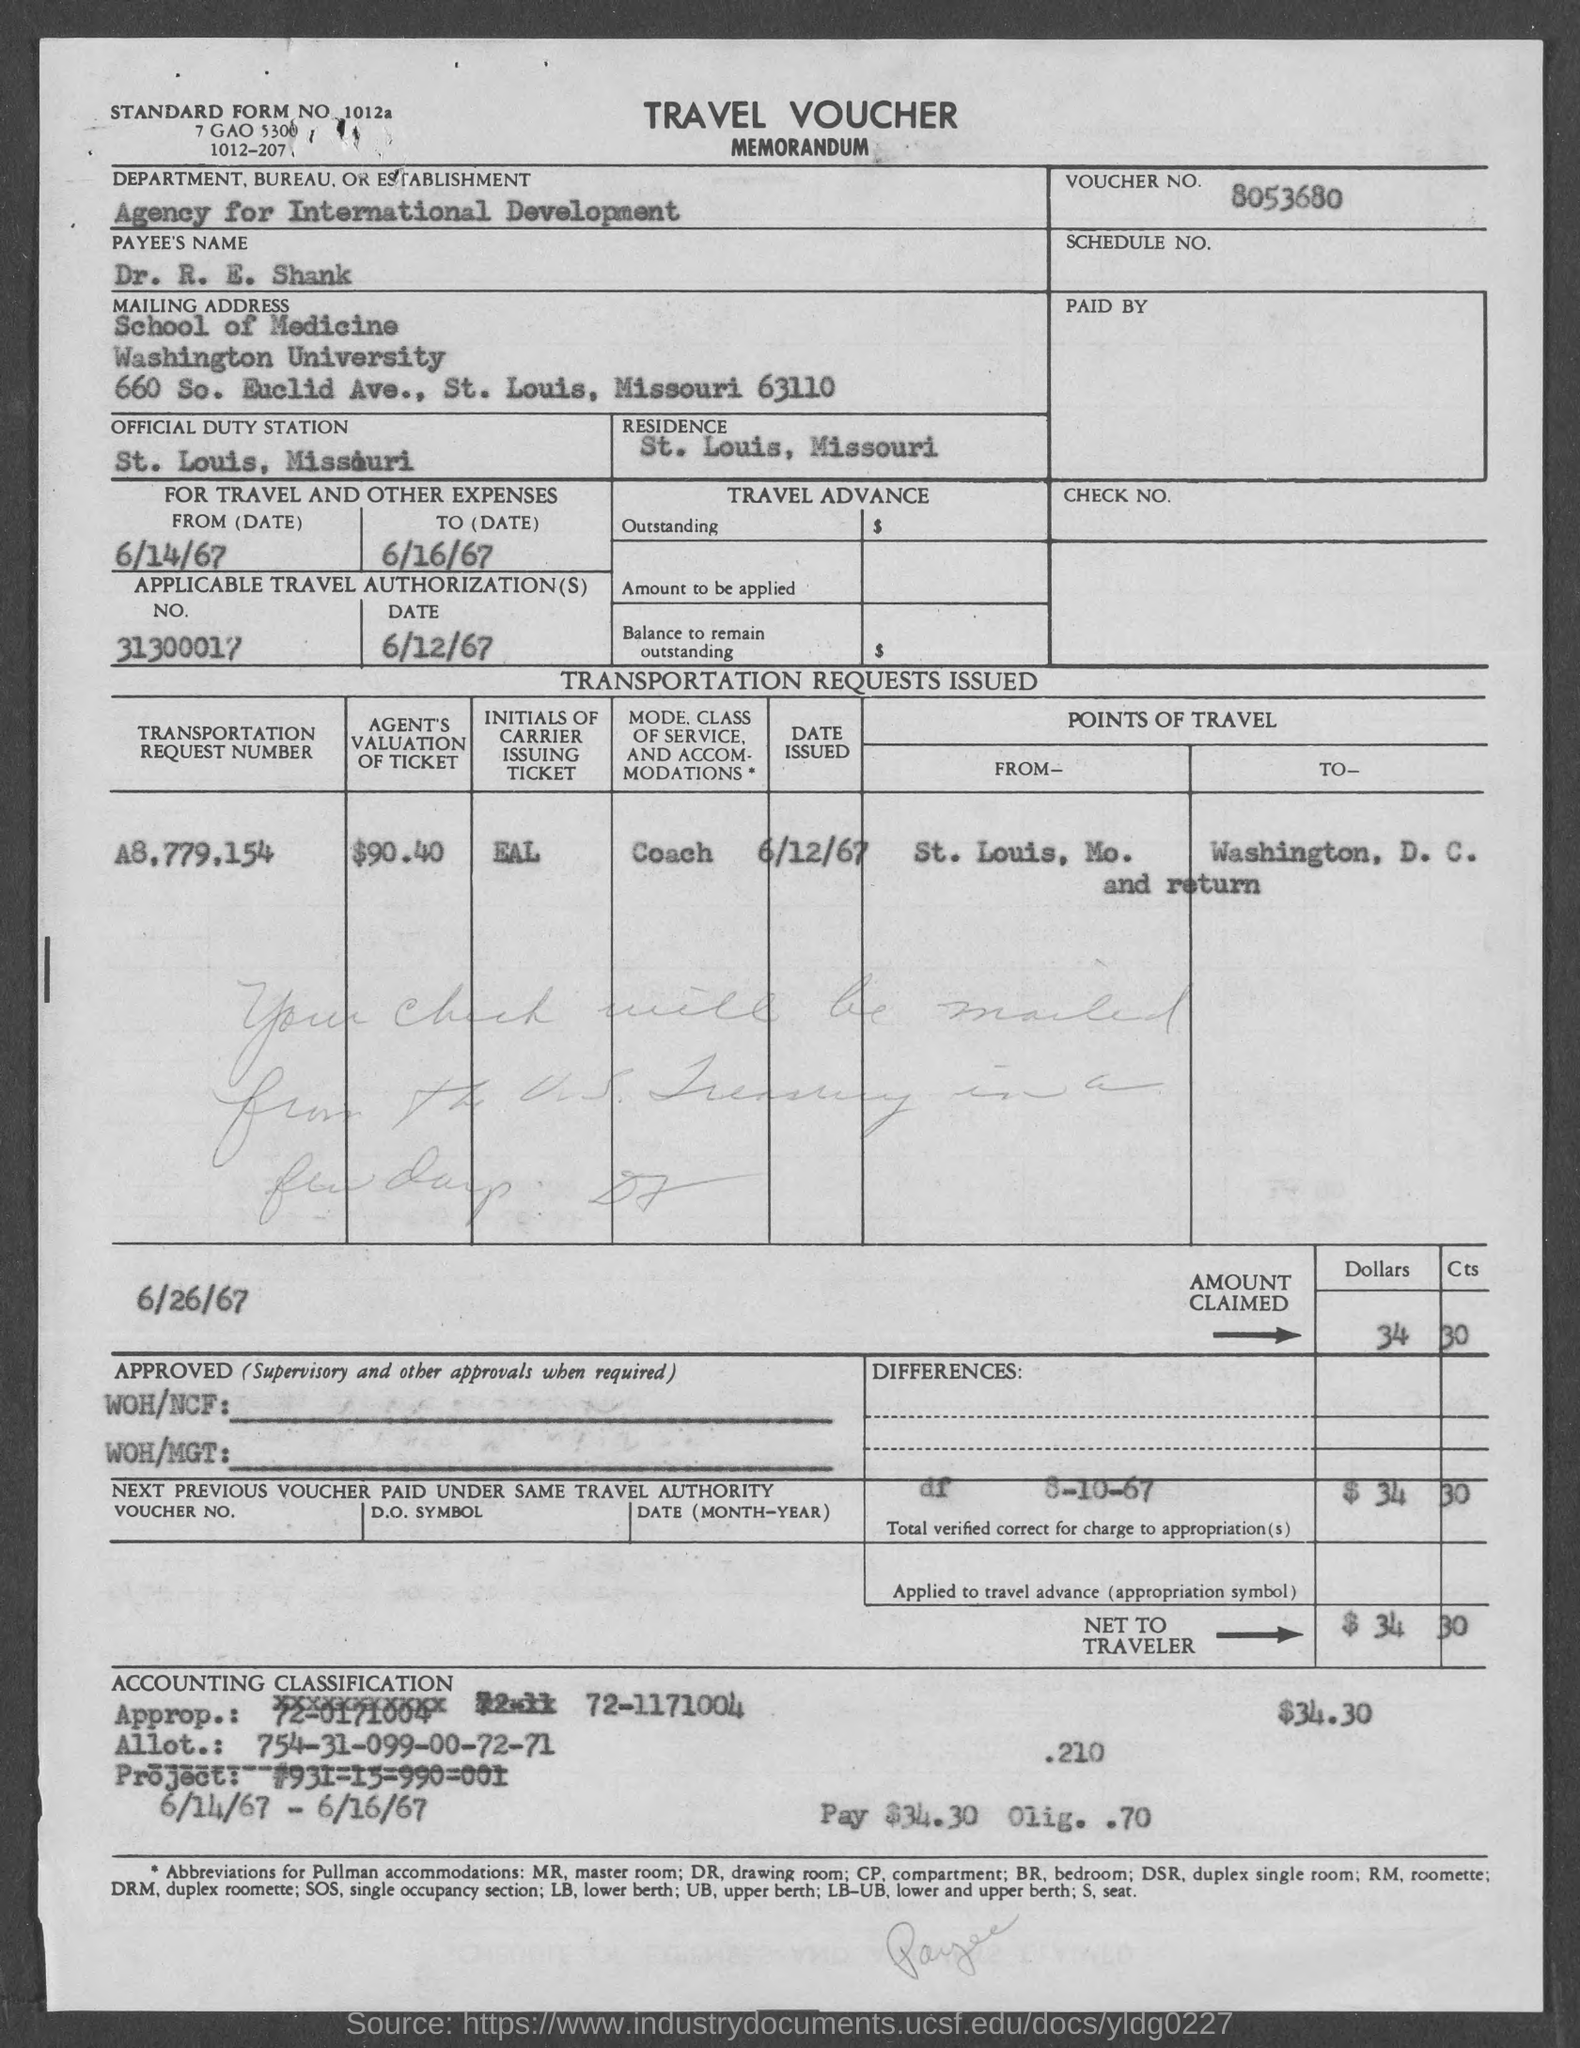What is the Standard Form No. given in the voucher?
Your answer should be compact. 1012a. What is the voucher no given in the memorandum?
Provide a short and direct response. 8053680. What is the Department, Bureau, or Establishment mentioned in the travel voucher?
Provide a short and direct response. Agency for International Development. What is the Payees Name given in the travel voucher?
Ensure brevity in your answer.  Dr. R. E. Shank. What is the applicable travel authorization date given in the travel voucher?
Give a very brief answer. 6/12/67. Which is the official duty station of Dr. R. E. Shank?
Offer a very short reply. St. louis, missouri. 